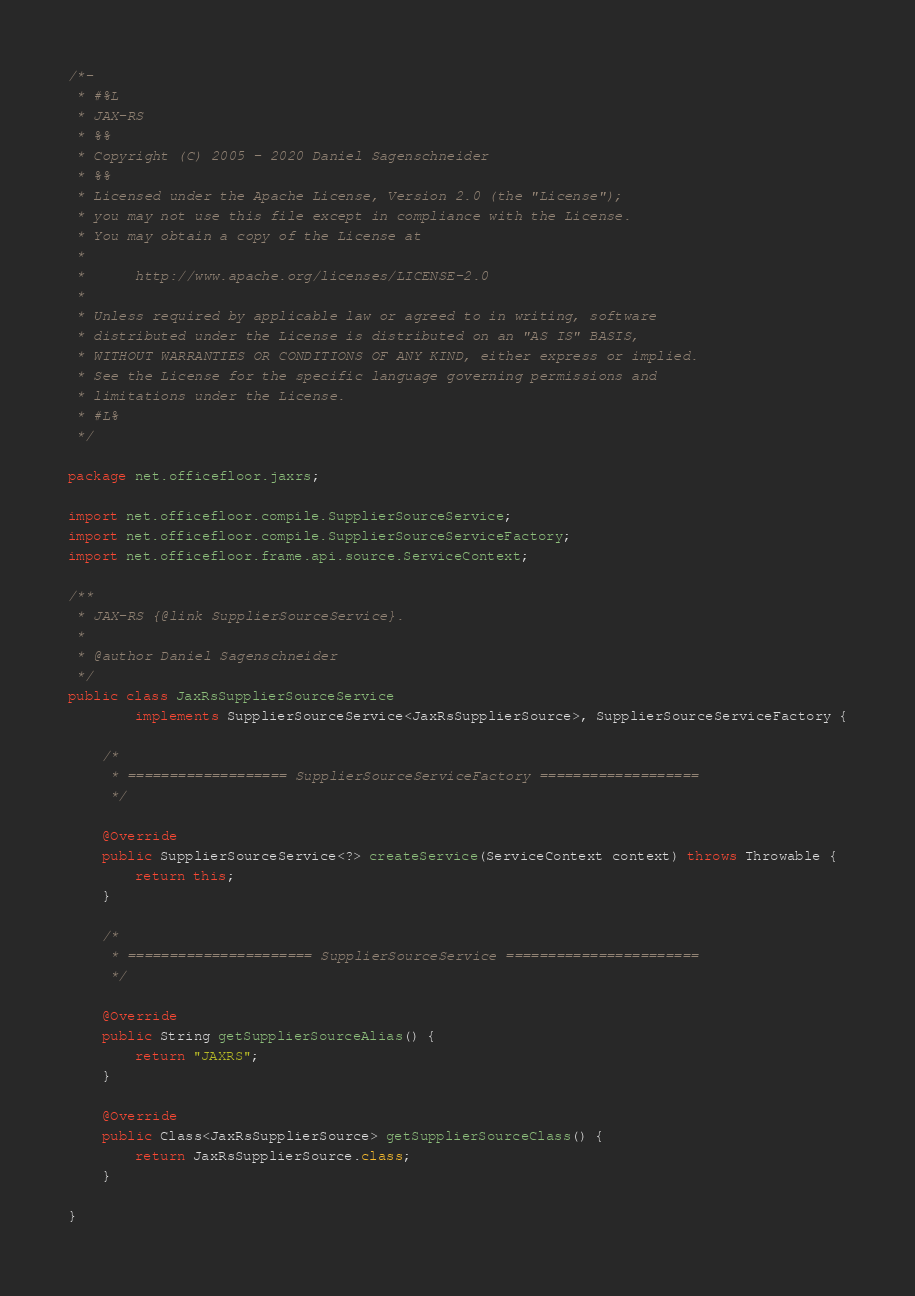Convert code to text. <code><loc_0><loc_0><loc_500><loc_500><_Java_>/*-
 * #%L
 * JAX-RS
 * %%
 * Copyright (C) 2005 - 2020 Daniel Sagenschneider
 * %%
 * Licensed under the Apache License, Version 2.0 (the "License");
 * you may not use this file except in compliance with the License.
 * You may obtain a copy of the License at
 * 
 *      http://www.apache.org/licenses/LICENSE-2.0
 * 
 * Unless required by applicable law or agreed to in writing, software
 * distributed under the License is distributed on an "AS IS" BASIS,
 * WITHOUT WARRANTIES OR CONDITIONS OF ANY KIND, either express or implied.
 * See the License for the specific language governing permissions and
 * limitations under the License.
 * #L%
 */

package net.officefloor.jaxrs;

import net.officefloor.compile.SupplierSourceService;
import net.officefloor.compile.SupplierSourceServiceFactory;
import net.officefloor.frame.api.source.ServiceContext;

/**
 * JAX-RS {@link SupplierSourceService}.
 * 
 * @author Daniel Sagenschneider
 */
public class JaxRsSupplierSourceService
		implements SupplierSourceService<JaxRsSupplierSource>, SupplierSourceServiceFactory {

	/*
	 * =================== SupplierSourceServiceFactory ===================
	 */

	@Override
	public SupplierSourceService<?> createService(ServiceContext context) throws Throwable {
		return this;
	}

	/*
	 * ====================== SupplierSourceService =======================
	 */

	@Override
	public String getSupplierSourceAlias() {
		return "JAXRS";
	}

	@Override
	public Class<JaxRsSupplierSource> getSupplierSourceClass() {
		return JaxRsSupplierSource.class;
	}

}
</code> 